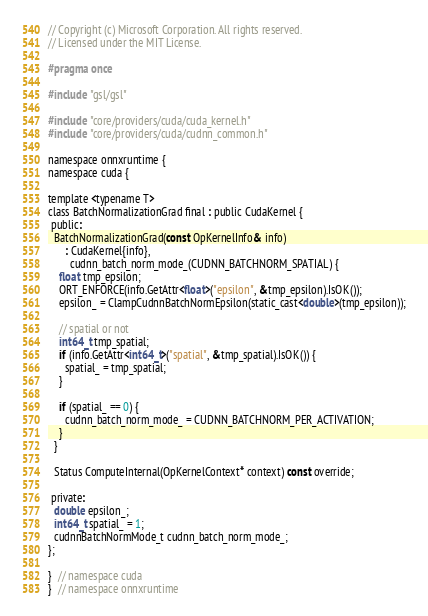Convert code to text. <code><loc_0><loc_0><loc_500><loc_500><_C_>// Copyright (c) Microsoft Corporation. All rights reserved.
// Licensed under the MIT License.

#pragma once

#include "gsl/gsl"

#include "core/providers/cuda/cuda_kernel.h"
#include "core/providers/cuda/cudnn_common.h"

namespace onnxruntime {
namespace cuda {

template <typename T>
class BatchNormalizationGrad final : public CudaKernel {
 public:
  BatchNormalizationGrad(const OpKernelInfo& info)
      : CudaKernel{info},
        cudnn_batch_norm_mode_(CUDNN_BATCHNORM_SPATIAL) {
    float tmp_epsilon;
    ORT_ENFORCE(info.GetAttr<float>("epsilon", &tmp_epsilon).IsOK());
    epsilon_ = ClampCudnnBatchNormEpsilon(static_cast<double>(tmp_epsilon));

    // spatial or not
    int64_t tmp_spatial;
    if (info.GetAttr<int64_t>("spatial", &tmp_spatial).IsOK()) {
      spatial_ = tmp_spatial;
    }

    if (spatial_ == 0) {
      cudnn_batch_norm_mode_ = CUDNN_BATCHNORM_PER_ACTIVATION;
    }
  }

  Status ComputeInternal(OpKernelContext* context) const override;

 private:
  double epsilon_;
  int64_t spatial_ = 1;
  cudnnBatchNormMode_t cudnn_batch_norm_mode_;
};

}  // namespace cuda
}  // namespace onnxruntime
</code> 